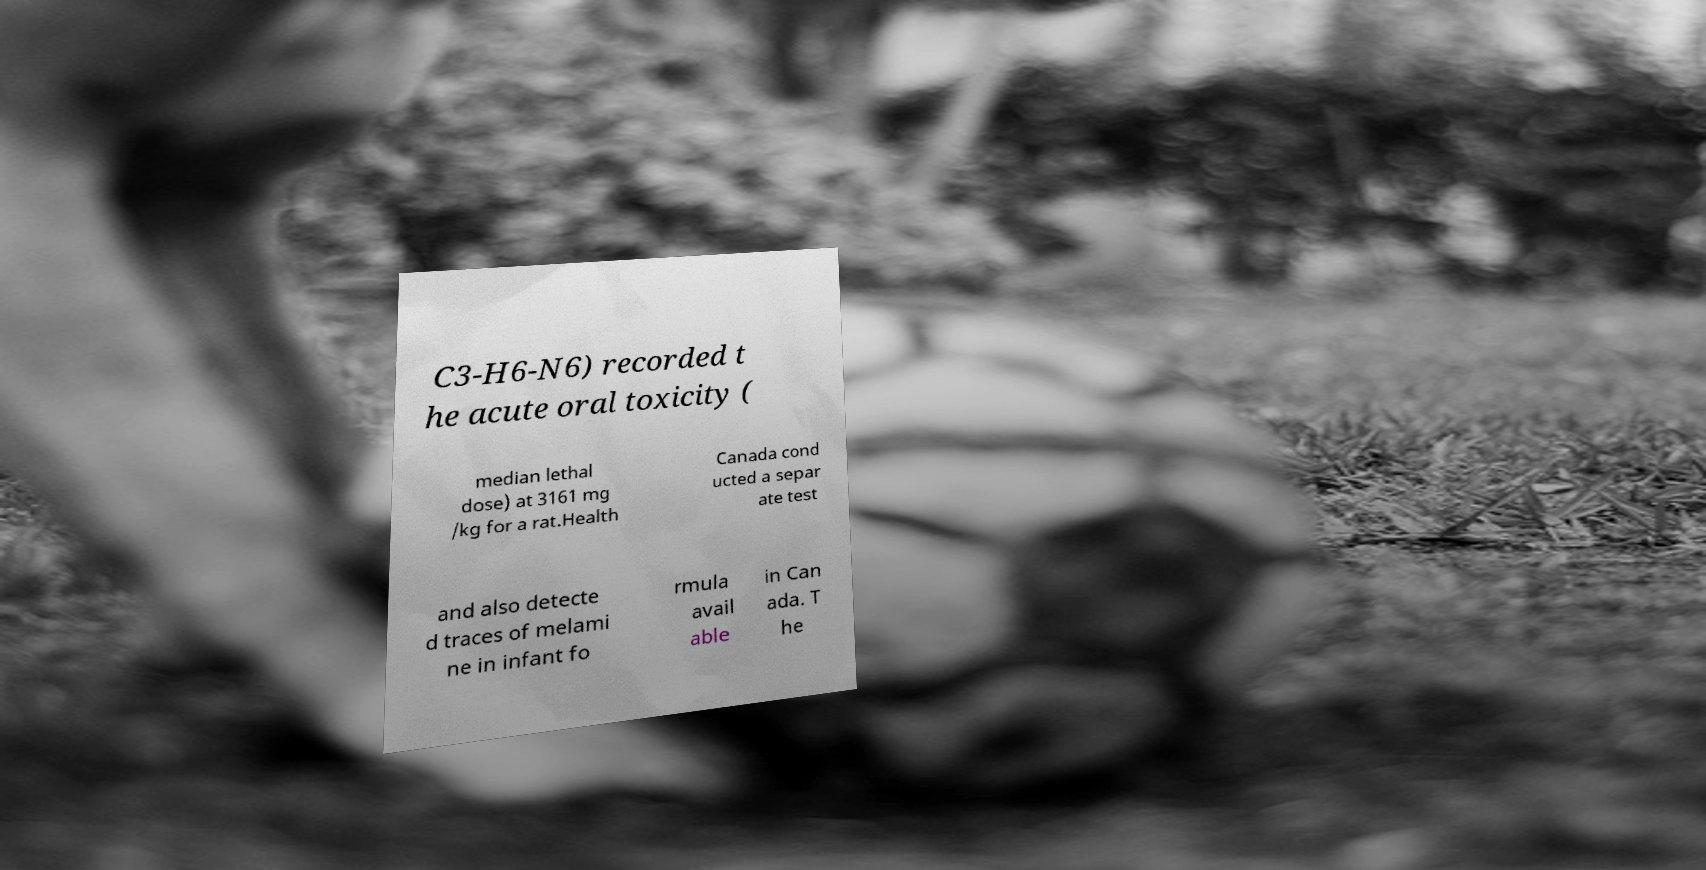Can you accurately transcribe the text from the provided image for me? C3-H6-N6) recorded t he acute oral toxicity ( median lethal dose) at 3161 mg /kg for a rat.Health Canada cond ucted a separ ate test and also detecte d traces of melami ne in infant fo rmula avail able in Can ada. T he 